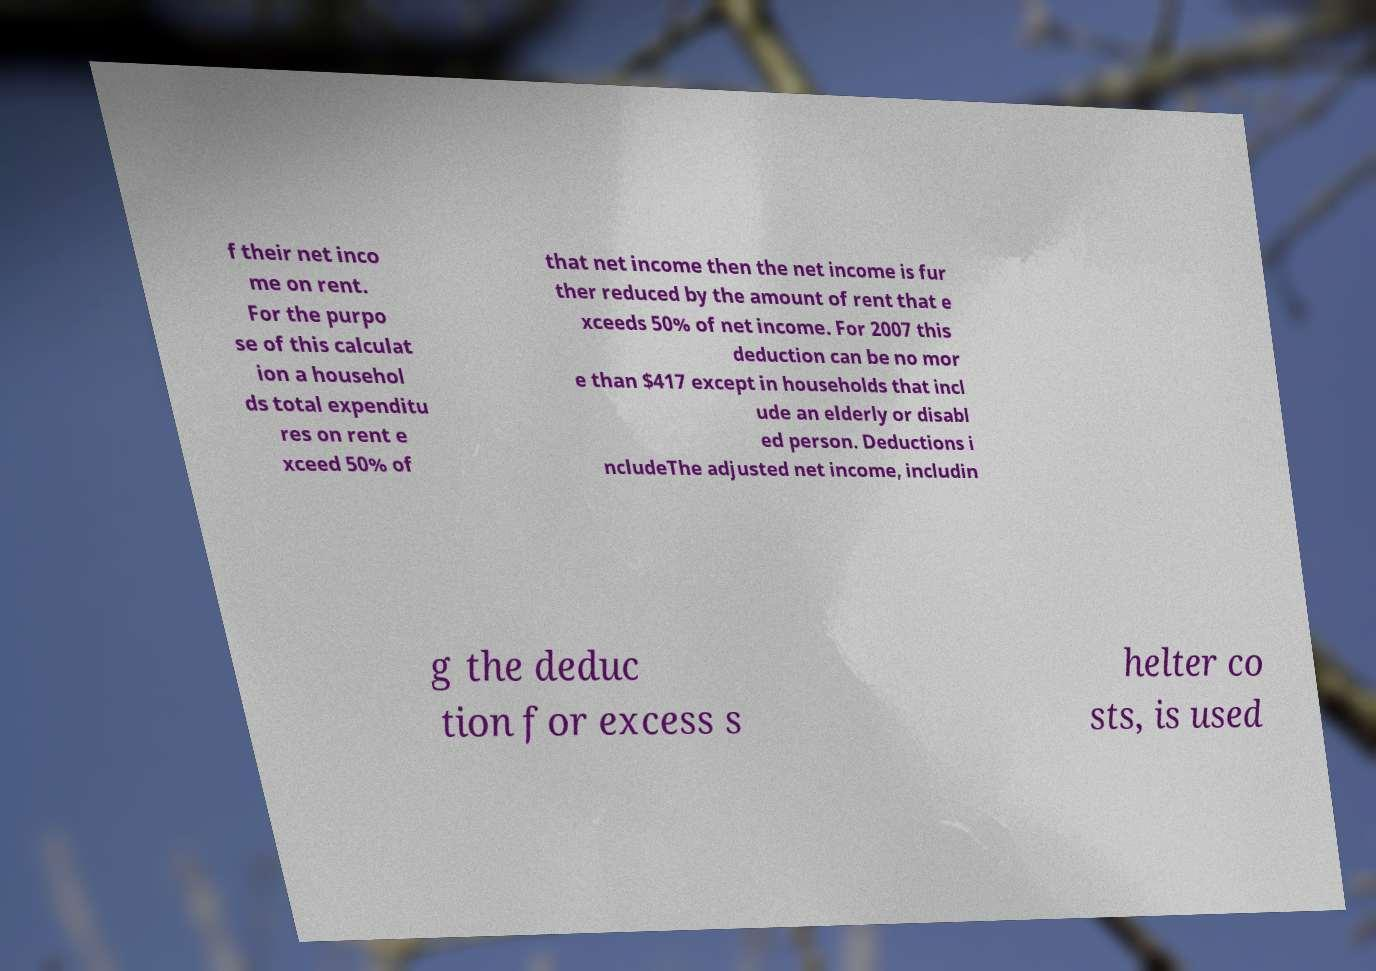Please identify and transcribe the text found in this image. f their net inco me on rent. For the purpo se of this calculat ion a househol ds total expenditu res on rent e xceed 50% of that net income then the net income is fur ther reduced by the amount of rent that e xceeds 50% of net income. For 2007 this deduction can be no mor e than $417 except in households that incl ude an elderly or disabl ed person. Deductions i ncludeThe adjusted net income, includin g the deduc tion for excess s helter co sts, is used 